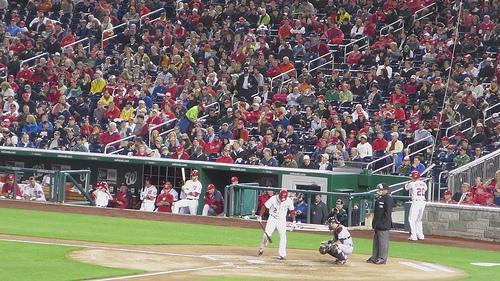How many people are around home plate?
Give a very brief answer. 3. 